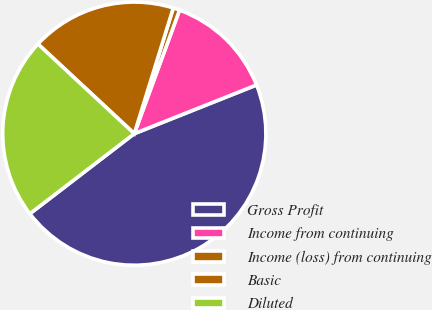<chart> <loc_0><loc_0><loc_500><loc_500><pie_chart><fcel>Gross Profit<fcel>Income from continuing<fcel>Income (loss) from continuing<fcel>Basic<fcel>Diluted<nl><fcel>45.62%<fcel>13.38%<fcel>0.8%<fcel>17.86%<fcel>22.34%<nl></chart> 